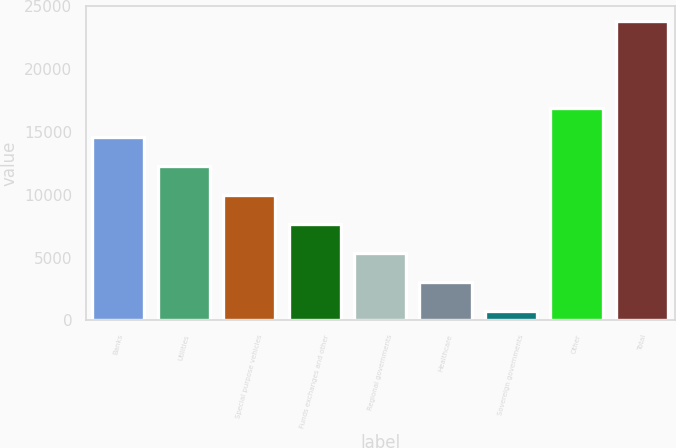<chart> <loc_0><loc_0><loc_500><loc_500><bar_chart><fcel>Banks<fcel>Utilities<fcel>Special purpose vehicles<fcel>Funds exchanges and other<fcel>Regional governments<fcel>Healthcare<fcel>Sovereign governments<fcel>Other<fcel>Total<nl><fcel>14627.4<fcel>12318<fcel>10008.6<fcel>7699.2<fcel>5389.8<fcel>3080.4<fcel>771<fcel>16936.8<fcel>23865<nl></chart> 